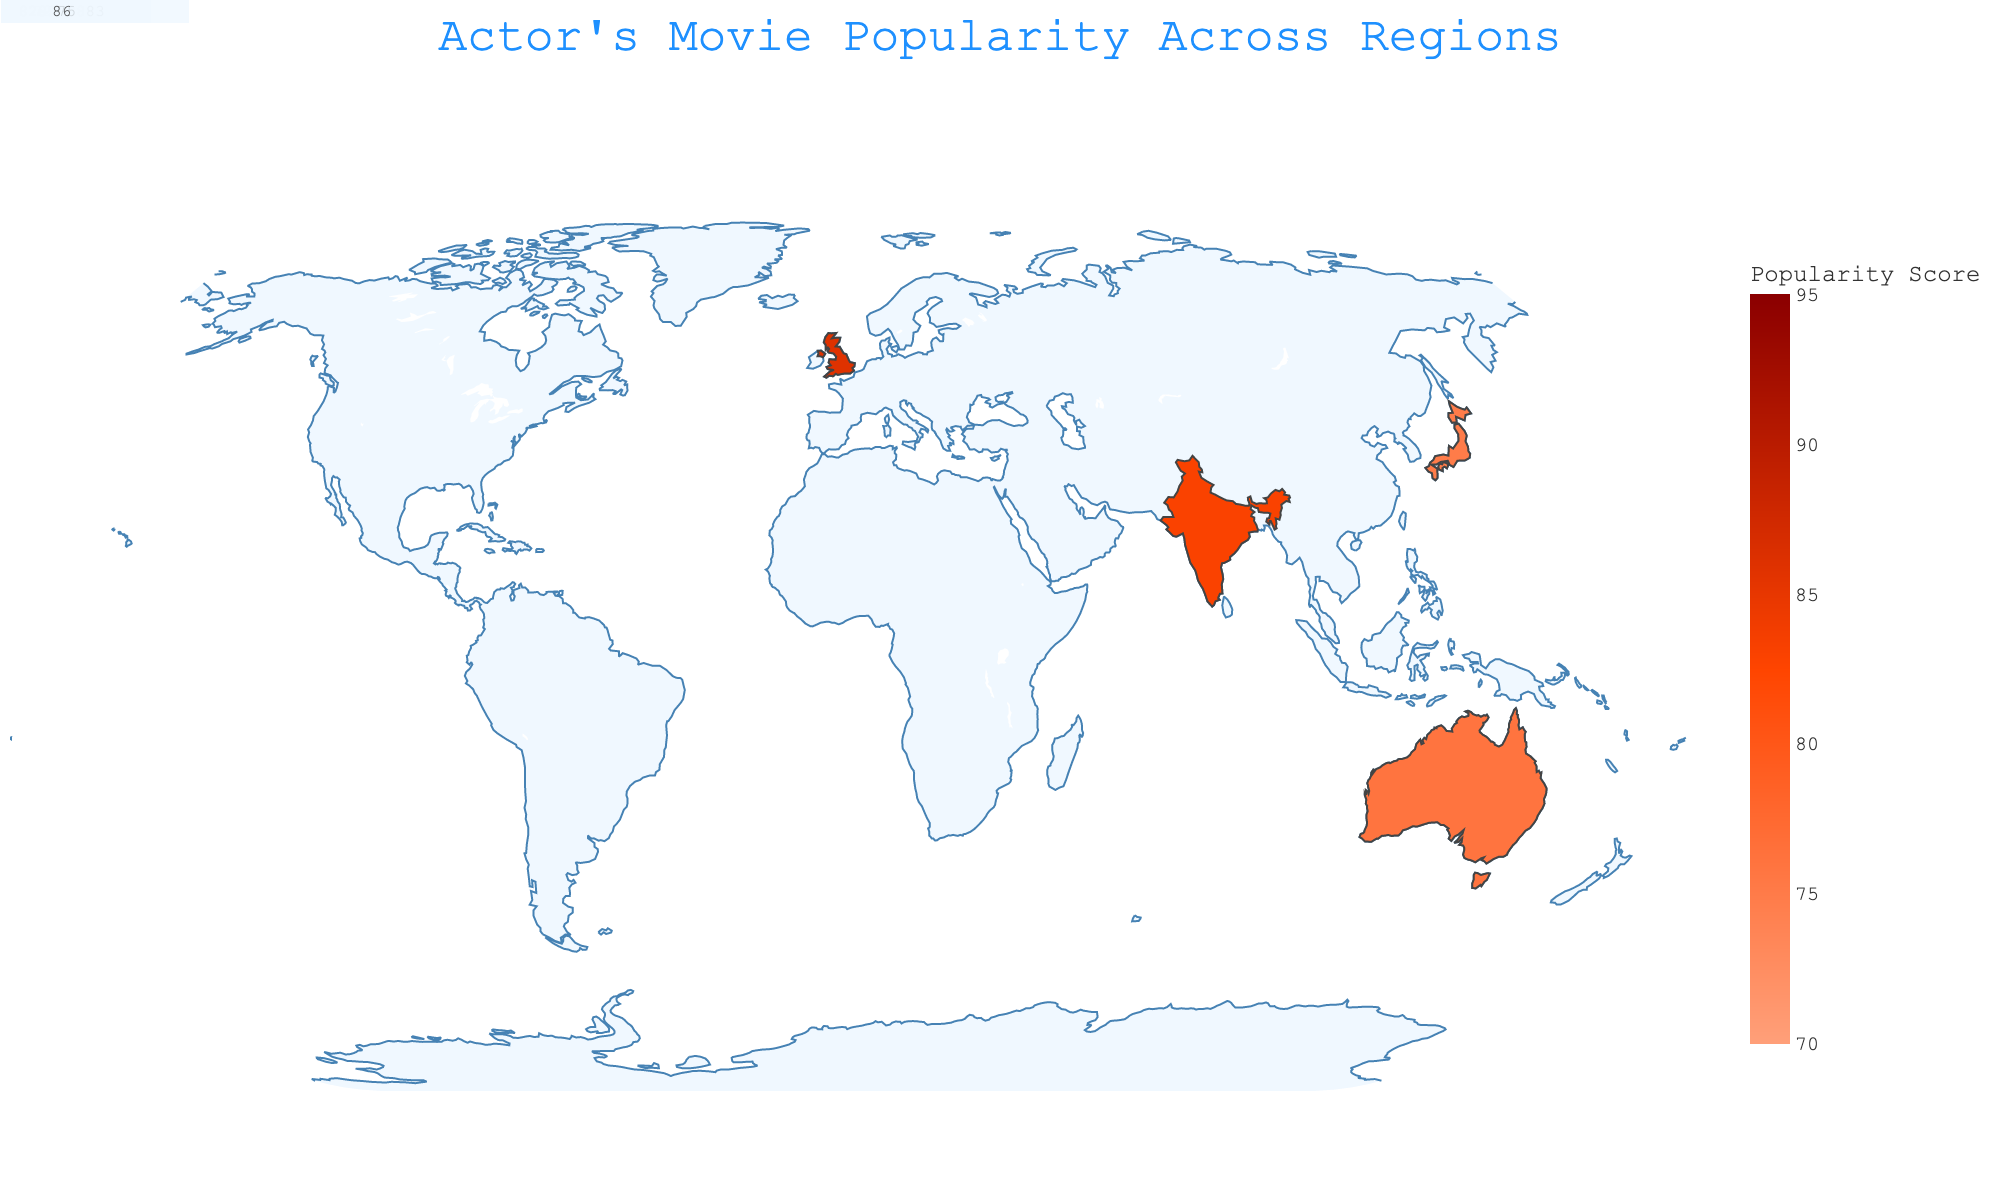Which region ranks highest in movie popularity for the actor's films? The highest Popularity Score in the plot is 92, which corresponds to "Inception" in North America.
Answer: North America Which movie is most popular in Europe, and what is its score? The plot shows "The Dark Knight" with a Popularity Score of 88 in Europe.
Answer: The Dark Knight, 88 Compare the Popularity Scores of "Interstellar" in South America and "Batman Begins" in Southeast Asia. Which one is higher? South America has a Popularity Score of 85 for "Interstellar," whereas Southeast Asia has a score of 80 for "Batman Begins." 85 > 80.
Answer: Interstellar What is the average Popularity Score of the movies in the regions of Africa and Australia? "Memento" in Africa has a score of 70, and "The Prestige" in Australia has a score of 76. The average is (70 + 76) / 2 = 73.
Answer: 73 Which regions have movie Popularity Scores below 75? Africa (70), Australia (76) and Central America (72) are the only regions with scores below 75.
Answer: Africa, Central America Does "The Departed" have a higher score than "Catch Me If You Can" in their respective regions? "The Departed" in the United Kingdom has a score of 86, and "Catch Me If You Can" in India has a score of 83. 86 > 83.
Answer: Yes How many regions have a Popularity Score of 85 or higher? North America (92), Europe (88), South America (85), Caribbean (90), Eastern Europe (87), India (83), and United Kingdom (86). There are 7 regions.
Answer: 7 What is the median Popularity Score of all the movies in different regions? The sorted Popularity Scores are 70, 72, 75, 76, 78, 79, 80, 82, 83, 85, 86, 87, 88, 90, 92. The median is the middle value, which is 82.
Answer: 82 Which region has the movie "Tenet," and what is the score? The plot shows "Tenet" in the Middle East with a Popularity Score of 82.
Answer: Middle East, 82 